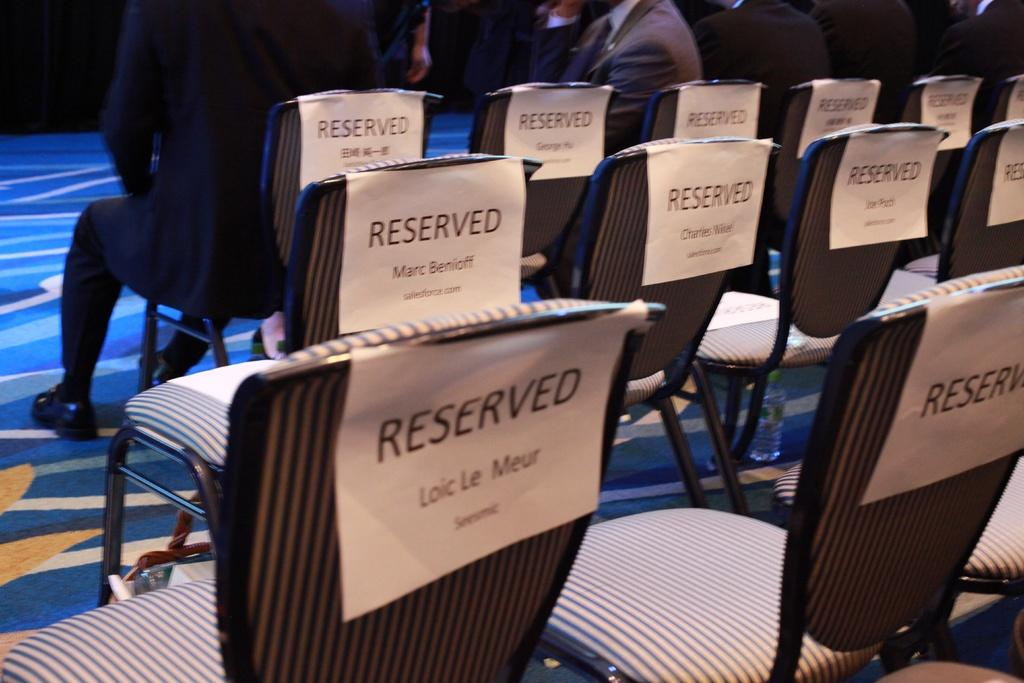<image>
Provide a brief description of the given image. An event is taking place and there is reserved seating for it. 